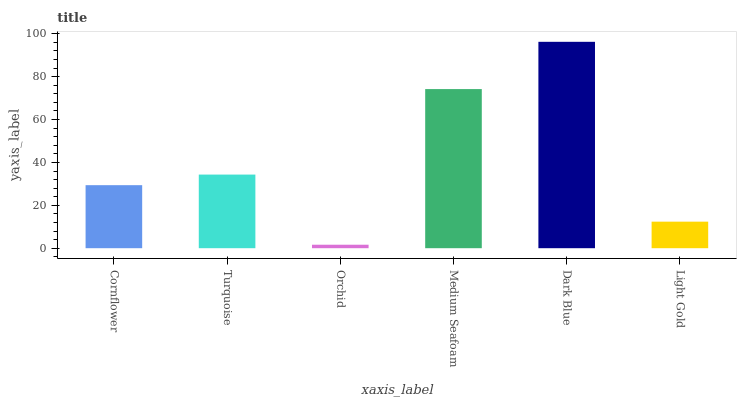Is Orchid the minimum?
Answer yes or no. Yes. Is Dark Blue the maximum?
Answer yes or no. Yes. Is Turquoise the minimum?
Answer yes or no. No. Is Turquoise the maximum?
Answer yes or no. No. Is Turquoise greater than Cornflower?
Answer yes or no. Yes. Is Cornflower less than Turquoise?
Answer yes or no. Yes. Is Cornflower greater than Turquoise?
Answer yes or no. No. Is Turquoise less than Cornflower?
Answer yes or no. No. Is Turquoise the high median?
Answer yes or no. Yes. Is Cornflower the low median?
Answer yes or no. Yes. Is Light Gold the high median?
Answer yes or no. No. Is Dark Blue the low median?
Answer yes or no. No. 